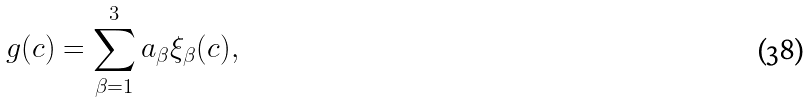<formula> <loc_0><loc_0><loc_500><loc_500>g ( c ) = \sum _ { \beta = 1 } ^ { 3 } a _ { \beta } \xi _ { \beta } ( c ) ,</formula> 